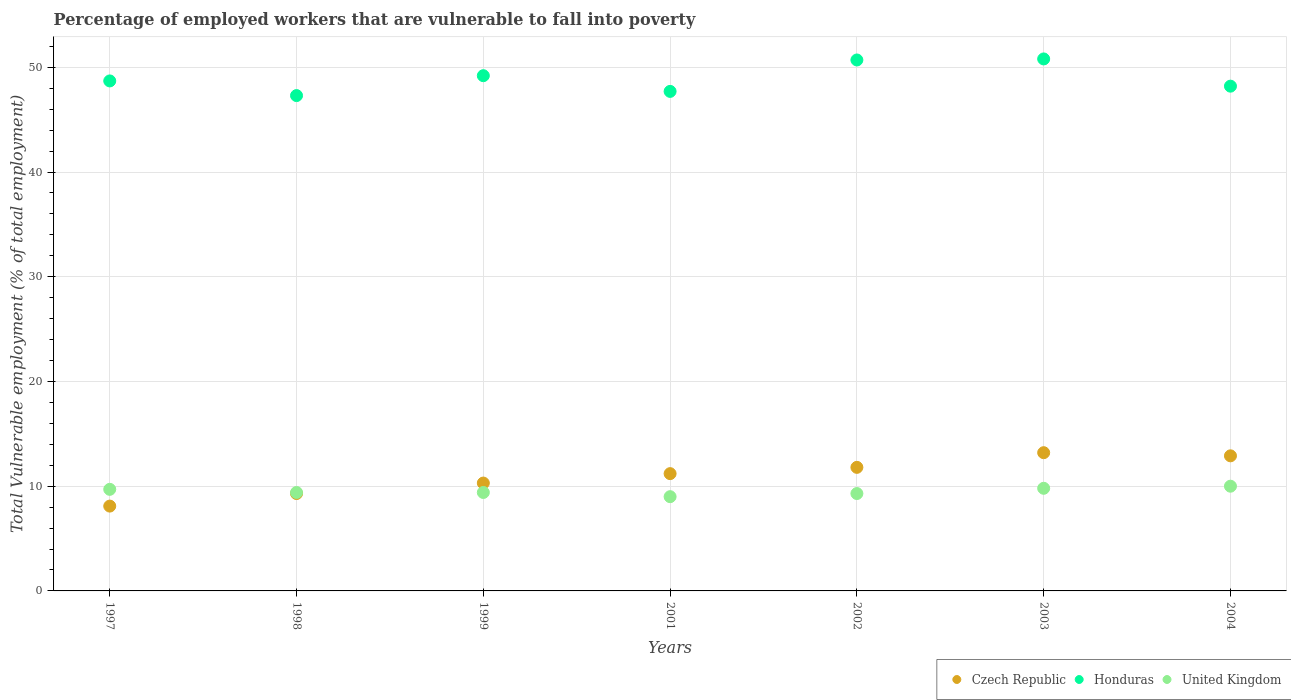How many different coloured dotlines are there?
Your answer should be compact. 3. What is the percentage of employed workers who are vulnerable to fall into poverty in United Kingdom in 2001?
Keep it short and to the point. 9. Across all years, what is the maximum percentage of employed workers who are vulnerable to fall into poverty in Honduras?
Provide a succinct answer. 50.8. Across all years, what is the minimum percentage of employed workers who are vulnerable to fall into poverty in Czech Republic?
Offer a very short reply. 8.1. What is the total percentage of employed workers who are vulnerable to fall into poverty in United Kingdom in the graph?
Ensure brevity in your answer.  66.6. What is the difference between the percentage of employed workers who are vulnerable to fall into poverty in Czech Republic in 2001 and that in 2002?
Offer a terse response. -0.6. What is the difference between the percentage of employed workers who are vulnerable to fall into poverty in Honduras in 2004 and the percentage of employed workers who are vulnerable to fall into poverty in United Kingdom in 2001?
Your response must be concise. 39.2. What is the average percentage of employed workers who are vulnerable to fall into poverty in Czech Republic per year?
Give a very brief answer. 10.97. In the year 1998, what is the difference between the percentage of employed workers who are vulnerable to fall into poverty in United Kingdom and percentage of employed workers who are vulnerable to fall into poverty in Czech Republic?
Offer a terse response. 0.1. What is the ratio of the percentage of employed workers who are vulnerable to fall into poverty in Honduras in 1997 to that in 2001?
Offer a very short reply. 1.02. Is the difference between the percentage of employed workers who are vulnerable to fall into poverty in United Kingdom in 1997 and 2004 greater than the difference between the percentage of employed workers who are vulnerable to fall into poverty in Czech Republic in 1997 and 2004?
Make the answer very short. Yes. What is the difference between the highest and the second highest percentage of employed workers who are vulnerable to fall into poverty in Czech Republic?
Provide a short and direct response. 0.3. What is the difference between the highest and the lowest percentage of employed workers who are vulnerable to fall into poverty in United Kingdom?
Your answer should be compact. 1. In how many years, is the percentage of employed workers who are vulnerable to fall into poverty in Honduras greater than the average percentage of employed workers who are vulnerable to fall into poverty in Honduras taken over all years?
Offer a very short reply. 3. Is the sum of the percentage of employed workers who are vulnerable to fall into poverty in Honduras in 2001 and 2004 greater than the maximum percentage of employed workers who are vulnerable to fall into poverty in Czech Republic across all years?
Your answer should be compact. Yes. Does the percentage of employed workers who are vulnerable to fall into poverty in Czech Republic monotonically increase over the years?
Keep it short and to the point. No. How many dotlines are there?
Your response must be concise. 3. How many years are there in the graph?
Provide a short and direct response. 7. What is the difference between two consecutive major ticks on the Y-axis?
Your answer should be very brief. 10. Does the graph contain any zero values?
Give a very brief answer. No. Does the graph contain grids?
Your answer should be very brief. Yes. Where does the legend appear in the graph?
Give a very brief answer. Bottom right. How many legend labels are there?
Provide a succinct answer. 3. How are the legend labels stacked?
Offer a very short reply. Horizontal. What is the title of the graph?
Keep it short and to the point. Percentage of employed workers that are vulnerable to fall into poverty. Does "Sint Maarten (Dutch part)" appear as one of the legend labels in the graph?
Offer a terse response. No. What is the label or title of the Y-axis?
Provide a succinct answer. Total Vulnerable employment (% of total employment). What is the Total Vulnerable employment (% of total employment) of Czech Republic in 1997?
Provide a short and direct response. 8.1. What is the Total Vulnerable employment (% of total employment) in Honduras in 1997?
Make the answer very short. 48.7. What is the Total Vulnerable employment (% of total employment) in United Kingdom in 1997?
Make the answer very short. 9.7. What is the Total Vulnerable employment (% of total employment) in Czech Republic in 1998?
Offer a terse response. 9.3. What is the Total Vulnerable employment (% of total employment) in Honduras in 1998?
Provide a short and direct response. 47.3. What is the Total Vulnerable employment (% of total employment) in United Kingdom in 1998?
Your answer should be compact. 9.4. What is the Total Vulnerable employment (% of total employment) of Czech Republic in 1999?
Make the answer very short. 10.3. What is the Total Vulnerable employment (% of total employment) in Honduras in 1999?
Provide a succinct answer. 49.2. What is the Total Vulnerable employment (% of total employment) in United Kingdom in 1999?
Your answer should be compact. 9.4. What is the Total Vulnerable employment (% of total employment) in Czech Republic in 2001?
Your answer should be very brief. 11.2. What is the Total Vulnerable employment (% of total employment) in Honduras in 2001?
Offer a very short reply. 47.7. What is the Total Vulnerable employment (% of total employment) in United Kingdom in 2001?
Give a very brief answer. 9. What is the Total Vulnerable employment (% of total employment) in Czech Republic in 2002?
Ensure brevity in your answer.  11.8. What is the Total Vulnerable employment (% of total employment) of Honduras in 2002?
Provide a succinct answer. 50.7. What is the Total Vulnerable employment (% of total employment) of United Kingdom in 2002?
Offer a terse response. 9.3. What is the Total Vulnerable employment (% of total employment) in Czech Republic in 2003?
Provide a succinct answer. 13.2. What is the Total Vulnerable employment (% of total employment) of Honduras in 2003?
Offer a terse response. 50.8. What is the Total Vulnerable employment (% of total employment) in United Kingdom in 2003?
Your response must be concise. 9.8. What is the Total Vulnerable employment (% of total employment) of Czech Republic in 2004?
Keep it short and to the point. 12.9. What is the Total Vulnerable employment (% of total employment) of Honduras in 2004?
Offer a terse response. 48.2. Across all years, what is the maximum Total Vulnerable employment (% of total employment) of Czech Republic?
Provide a short and direct response. 13.2. Across all years, what is the maximum Total Vulnerable employment (% of total employment) in Honduras?
Make the answer very short. 50.8. Across all years, what is the maximum Total Vulnerable employment (% of total employment) of United Kingdom?
Provide a short and direct response. 10. Across all years, what is the minimum Total Vulnerable employment (% of total employment) in Czech Republic?
Ensure brevity in your answer.  8.1. Across all years, what is the minimum Total Vulnerable employment (% of total employment) in Honduras?
Your answer should be very brief. 47.3. Across all years, what is the minimum Total Vulnerable employment (% of total employment) in United Kingdom?
Offer a very short reply. 9. What is the total Total Vulnerable employment (% of total employment) of Czech Republic in the graph?
Offer a very short reply. 76.8. What is the total Total Vulnerable employment (% of total employment) in Honduras in the graph?
Your answer should be compact. 342.6. What is the total Total Vulnerable employment (% of total employment) in United Kingdom in the graph?
Make the answer very short. 66.6. What is the difference between the Total Vulnerable employment (% of total employment) in Czech Republic in 1997 and that in 1998?
Provide a short and direct response. -1.2. What is the difference between the Total Vulnerable employment (% of total employment) in Czech Republic in 1997 and that in 2001?
Provide a succinct answer. -3.1. What is the difference between the Total Vulnerable employment (% of total employment) of Czech Republic in 1997 and that in 2002?
Make the answer very short. -3.7. What is the difference between the Total Vulnerable employment (% of total employment) in Honduras in 1997 and that in 2002?
Make the answer very short. -2. What is the difference between the Total Vulnerable employment (% of total employment) of United Kingdom in 1997 and that in 2002?
Provide a short and direct response. 0.4. What is the difference between the Total Vulnerable employment (% of total employment) of Czech Republic in 1997 and that in 2003?
Provide a succinct answer. -5.1. What is the difference between the Total Vulnerable employment (% of total employment) of Honduras in 1997 and that in 2003?
Make the answer very short. -2.1. What is the difference between the Total Vulnerable employment (% of total employment) in Honduras in 1997 and that in 2004?
Provide a short and direct response. 0.5. What is the difference between the Total Vulnerable employment (% of total employment) in United Kingdom in 1998 and that in 1999?
Provide a succinct answer. 0. What is the difference between the Total Vulnerable employment (% of total employment) of Czech Republic in 1998 and that in 2001?
Offer a very short reply. -1.9. What is the difference between the Total Vulnerable employment (% of total employment) in Honduras in 1998 and that in 2001?
Offer a very short reply. -0.4. What is the difference between the Total Vulnerable employment (% of total employment) of United Kingdom in 1998 and that in 2001?
Offer a very short reply. 0.4. What is the difference between the Total Vulnerable employment (% of total employment) in Czech Republic in 1998 and that in 2003?
Give a very brief answer. -3.9. What is the difference between the Total Vulnerable employment (% of total employment) of Czech Republic in 1998 and that in 2004?
Provide a short and direct response. -3.6. What is the difference between the Total Vulnerable employment (% of total employment) in Honduras in 1998 and that in 2004?
Make the answer very short. -0.9. What is the difference between the Total Vulnerable employment (% of total employment) of United Kingdom in 1998 and that in 2004?
Ensure brevity in your answer.  -0.6. What is the difference between the Total Vulnerable employment (% of total employment) in United Kingdom in 1999 and that in 2001?
Your answer should be very brief. 0.4. What is the difference between the Total Vulnerable employment (% of total employment) in Czech Republic in 1999 and that in 2002?
Provide a short and direct response. -1.5. What is the difference between the Total Vulnerable employment (% of total employment) in Honduras in 1999 and that in 2002?
Ensure brevity in your answer.  -1.5. What is the difference between the Total Vulnerable employment (% of total employment) in United Kingdom in 1999 and that in 2002?
Give a very brief answer. 0.1. What is the difference between the Total Vulnerable employment (% of total employment) of Czech Republic in 1999 and that in 2003?
Make the answer very short. -2.9. What is the difference between the Total Vulnerable employment (% of total employment) of Czech Republic in 1999 and that in 2004?
Ensure brevity in your answer.  -2.6. What is the difference between the Total Vulnerable employment (% of total employment) in Honduras in 1999 and that in 2004?
Keep it short and to the point. 1. What is the difference between the Total Vulnerable employment (% of total employment) in United Kingdom in 1999 and that in 2004?
Provide a short and direct response. -0.6. What is the difference between the Total Vulnerable employment (% of total employment) in Czech Republic in 2001 and that in 2002?
Offer a very short reply. -0.6. What is the difference between the Total Vulnerable employment (% of total employment) of Honduras in 2001 and that in 2002?
Provide a succinct answer. -3. What is the difference between the Total Vulnerable employment (% of total employment) of United Kingdom in 2001 and that in 2002?
Offer a very short reply. -0.3. What is the difference between the Total Vulnerable employment (% of total employment) of Czech Republic in 2001 and that in 2003?
Keep it short and to the point. -2. What is the difference between the Total Vulnerable employment (% of total employment) in Honduras in 2001 and that in 2003?
Make the answer very short. -3.1. What is the difference between the Total Vulnerable employment (% of total employment) in Honduras in 2001 and that in 2004?
Give a very brief answer. -0.5. What is the difference between the Total Vulnerable employment (% of total employment) in United Kingdom in 2001 and that in 2004?
Your answer should be very brief. -1. What is the difference between the Total Vulnerable employment (% of total employment) in Honduras in 2002 and that in 2003?
Your response must be concise. -0.1. What is the difference between the Total Vulnerable employment (% of total employment) of United Kingdom in 2002 and that in 2004?
Make the answer very short. -0.7. What is the difference between the Total Vulnerable employment (% of total employment) in Czech Republic in 2003 and that in 2004?
Offer a very short reply. 0.3. What is the difference between the Total Vulnerable employment (% of total employment) of Czech Republic in 1997 and the Total Vulnerable employment (% of total employment) of Honduras in 1998?
Your answer should be compact. -39.2. What is the difference between the Total Vulnerable employment (% of total employment) of Czech Republic in 1997 and the Total Vulnerable employment (% of total employment) of United Kingdom in 1998?
Provide a short and direct response. -1.3. What is the difference between the Total Vulnerable employment (% of total employment) in Honduras in 1997 and the Total Vulnerable employment (% of total employment) in United Kingdom in 1998?
Give a very brief answer. 39.3. What is the difference between the Total Vulnerable employment (% of total employment) of Czech Republic in 1997 and the Total Vulnerable employment (% of total employment) of Honduras in 1999?
Provide a succinct answer. -41.1. What is the difference between the Total Vulnerable employment (% of total employment) in Czech Republic in 1997 and the Total Vulnerable employment (% of total employment) in United Kingdom in 1999?
Give a very brief answer. -1.3. What is the difference between the Total Vulnerable employment (% of total employment) of Honduras in 1997 and the Total Vulnerable employment (% of total employment) of United Kingdom in 1999?
Make the answer very short. 39.3. What is the difference between the Total Vulnerable employment (% of total employment) in Czech Republic in 1997 and the Total Vulnerable employment (% of total employment) in Honduras in 2001?
Make the answer very short. -39.6. What is the difference between the Total Vulnerable employment (% of total employment) of Czech Republic in 1997 and the Total Vulnerable employment (% of total employment) of United Kingdom in 2001?
Your answer should be compact. -0.9. What is the difference between the Total Vulnerable employment (% of total employment) in Honduras in 1997 and the Total Vulnerable employment (% of total employment) in United Kingdom in 2001?
Ensure brevity in your answer.  39.7. What is the difference between the Total Vulnerable employment (% of total employment) in Czech Republic in 1997 and the Total Vulnerable employment (% of total employment) in Honduras in 2002?
Offer a terse response. -42.6. What is the difference between the Total Vulnerable employment (% of total employment) of Honduras in 1997 and the Total Vulnerable employment (% of total employment) of United Kingdom in 2002?
Make the answer very short. 39.4. What is the difference between the Total Vulnerable employment (% of total employment) in Czech Republic in 1997 and the Total Vulnerable employment (% of total employment) in Honduras in 2003?
Provide a succinct answer. -42.7. What is the difference between the Total Vulnerable employment (% of total employment) in Honduras in 1997 and the Total Vulnerable employment (% of total employment) in United Kingdom in 2003?
Give a very brief answer. 38.9. What is the difference between the Total Vulnerable employment (% of total employment) of Czech Republic in 1997 and the Total Vulnerable employment (% of total employment) of Honduras in 2004?
Offer a very short reply. -40.1. What is the difference between the Total Vulnerable employment (% of total employment) in Czech Republic in 1997 and the Total Vulnerable employment (% of total employment) in United Kingdom in 2004?
Keep it short and to the point. -1.9. What is the difference between the Total Vulnerable employment (% of total employment) in Honduras in 1997 and the Total Vulnerable employment (% of total employment) in United Kingdom in 2004?
Offer a very short reply. 38.7. What is the difference between the Total Vulnerable employment (% of total employment) of Czech Republic in 1998 and the Total Vulnerable employment (% of total employment) of Honduras in 1999?
Make the answer very short. -39.9. What is the difference between the Total Vulnerable employment (% of total employment) of Honduras in 1998 and the Total Vulnerable employment (% of total employment) of United Kingdom in 1999?
Offer a very short reply. 37.9. What is the difference between the Total Vulnerable employment (% of total employment) in Czech Republic in 1998 and the Total Vulnerable employment (% of total employment) in Honduras in 2001?
Offer a very short reply. -38.4. What is the difference between the Total Vulnerable employment (% of total employment) in Czech Republic in 1998 and the Total Vulnerable employment (% of total employment) in United Kingdom in 2001?
Make the answer very short. 0.3. What is the difference between the Total Vulnerable employment (% of total employment) in Honduras in 1998 and the Total Vulnerable employment (% of total employment) in United Kingdom in 2001?
Provide a short and direct response. 38.3. What is the difference between the Total Vulnerable employment (% of total employment) in Czech Republic in 1998 and the Total Vulnerable employment (% of total employment) in Honduras in 2002?
Ensure brevity in your answer.  -41.4. What is the difference between the Total Vulnerable employment (% of total employment) in Czech Republic in 1998 and the Total Vulnerable employment (% of total employment) in United Kingdom in 2002?
Ensure brevity in your answer.  0. What is the difference between the Total Vulnerable employment (% of total employment) in Honduras in 1998 and the Total Vulnerable employment (% of total employment) in United Kingdom in 2002?
Your response must be concise. 38. What is the difference between the Total Vulnerable employment (% of total employment) of Czech Republic in 1998 and the Total Vulnerable employment (% of total employment) of Honduras in 2003?
Your answer should be very brief. -41.5. What is the difference between the Total Vulnerable employment (% of total employment) of Honduras in 1998 and the Total Vulnerable employment (% of total employment) of United Kingdom in 2003?
Keep it short and to the point. 37.5. What is the difference between the Total Vulnerable employment (% of total employment) in Czech Republic in 1998 and the Total Vulnerable employment (% of total employment) in Honduras in 2004?
Your response must be concise. -38.9. What is the difference between the Total Vulnerable employment (% of total employment) of Czech Republic in 1998 and the Total Vulnerable employment (% of total employment) of United Kingdom in 2004?
Offer a terse response. -0.7. What is the difference between the Total Vulnerable employment (% of total employment) of Honduras in 1998 and the Total Vulnerable employment (% of total employment) of United Kingdom in 2004?
Offer a terse response. 37.3. What is the difference between the Total Vulnerable employment (% of total employment) of Czech Republic in 1999 and the Total Vulnerable employment (% of total employment) of Honduras in 2001?
Your answer should be very brief. -37.4. What is the difference between the Total Vulnerable employment (% of total employment) of Czech Republic in 1999 and the Total Vulnerable employment (% of total employment) of United Kingdom in 2001?
Your answer should be compact. 1.3. What is the difference between the Total Vulnerable employment (% of total employment) of Honduras in 1999 and the Total Vulnerable employment (% of total employment) of United Kingdom in 2001?
Your answer should be very brief. 40.2. What is the difference between the Total Vulnerable employment (% of total employment) in Czech Republic in 1999 and the Total Vulnerable employment (% of total employment) in Honduras in 2002?
Ensure brevity in your answer.  -40.4. What is the difference between the Total Vulnerable employment (% of total employment) of Honduras in 1999 and the Total Vulnerable employment (% of total employment) of United Kingdom in 2002?
Your answer should be compact. 39.9. What is the difference between the Total Vulnerable employment (% of total employment) in Czech Republic in 1999 and the Total Vulnerable employment (% of total employment) in Honduras in 2003?
Provide a short and direct response. -40.5. What is the difference between the Total Vulnerable employment (% of total employment) in Honduras in 1999 and the Total Vulnerable employment (% of total employment) in United Kingdom in 2003?
Give a very brief answer. 39.4. What is the difference between the Total Vulnerable employment (% of total employment) in Czech Republic in 1999 and the Total Vulnerable employment (% of total employment) in Honduras in 2004?
Offer a very short reply. -37.9. What is the difference between the Total Vulnerable employment (% of total employment) in Honduras in 1999 and the Total Vulnerable employment (% of total employment) in United Kingdom in 2004?
Your answer should be very brief. 39.2. What is the difference between the Total Vulnerable employment (% of total employment) in Czech Republic in 2001 and the Total Vulnerable employment (% of total employment) in Honduras in 2002?
Offer a terse response. -39.5. What is the difference between the Total Vulnerable employment (% of total employment) in Honduras in 2001 and the Total Vulnerable employment (% of total employment) in United Kingdom in 2002?
Your answer should be compact. 38.4. What is the difference between the Total Vulnerable employment (% of total employment) in Czech Republic in 2001 and the Total Vulnerable employment (% of total employment) in Honduras in 2003?
Offer a terse response. -39.6. What is the difference between the Total Vulnerable employment (% of total employment) of Czech Republic in 2001 and the Total Vulnerable employment (% of total employment) of United Kingdom in 2003?
Ensure brevity in your answer.  1.4. What is the difference between the Total Vulnerable employment (% of total employment) in Honduras in 2001 and the Total Vulnerable employment (% of total employment) in United Kingdom in 2003?
Keep it short and to the point. 37.9. What is the difference between the Total Vulnerable employment (% of total employment) of Czech Republic in 2001 and the Total Vulnerable employment (% of total employment) of Honduras in 2004?
Your response must be concise. -37. What is the difference between the Total Vulnerable employment (% of total employment) of Czech Republic in 2001 and the Total Vulnerable employment (% of total employment) of United Kingdom in 2004?
Your answer should be very brief. 1.2. What is the difference between the Total Vulnerable employment (% of total employment) of Honduras in 2001 and the Total Vulnerable employment (% of total employment) of United Kingdom in 2004?
Your response must be concise. 37.7. What is the difference between the Total Vulnerable employment (% of total employment) of Czech Republic in 2002 and the Total Vulnerable employment (% of total employment) of Honduras in 2003?
Your response must be concise. -39. What is the difference between the Total Vulnerable employment (% of total employment) in Honduras in 2002 and the Total Vulnerable employment (% of total employment) in United Kingdom in 2003?
Provide a short and direct response. 40.9. What is the difference between the Total Vulnerable employment (% of total employment) of Czech Republic in 2002 and the Total Vulnerable employment (% of total employment) of Honduras in 2004?
Give a very brief answer. -36.4. What is the difference between the Total Vulnerable employment (% of total employment) of Honduras in 2002 and the Total Vulnerable employment (% of total employment) of United Kingdom in 2004?
Make the answer very short. 40.7. What is the difference between the Total Vulnerable employment (% of total employment) of Czech Republic in 2003 and the Total Vulnerable employment (% of total employment) of Honduras in 2004?
Ensure brevity in your answer.  -35. What is the difference between the Total Vulnerable employment (% of total employment) of Honduras in 2003 and the Total Vulnerable employment (% of total employment) of United Kingdom in 2004?
Ensure brevity in your answer.  40.8. What is the average Total Vulnerable employment (% of total employment) of Czech Republic per year?
Make the answer very short. 10.97. What is the average Total Vulnerable employment (% of total employment) in Honduras per year?
Your answer should be compact. 48.94. What is the average Total Vulnerable employment (% of total employment) of United Kingdom per year?
Offer a very short reply. 9.51. In the year 1997, what is the difference between the Total Vulnerable employment (% of total employment) of Czech Republic and Total Vulnerable employment (% of total employment) of Honduras?
Make the answer very short. -40.6. In the year 1997, what is the difference between the Total Vulnerable employment (% of total employment) in Czech Republic and Total Vulnerable employment (% of total employment) in United Kingdom?
Ensure brevity in your answer.  -1.6. In the year 1998, what is the difference between the Total Vulnerable employment (% of total employment) in Czech Republic and Total Vulnerable employment (% of total employment) in Honduras?
Keep it short and to the point. -38. In the year 1998, what is the difference between the Total Vulnerable employment (% of total employment) in Honduras and Total Vulnerable employment (% of total employment) in United Kingdom?
Provide a short and direct response. 37.9. In the year 1999, what is the difference between the Total Vulnerable employment (% of total employment) in Czech Republic and Total Vulnerable employment (% of total employment) in Honduras?
Your answer should be compact. -38.9. In the year 1999, what is the difference between the Total Vulnerable employment (% of total employment) in Czech Republic and Total Vulnerable employment (% of total employment) in United Kingdom?
Your answer should be compact. 0.9. In the year 1999, what is the difference between the Total Vulnerable employment (% of total employment) in Honduras and Total Vulnerable employment (% of total employment) in United Kingdom?
Your answer should be compact. 39.8. In the year 2001, what is the difference between the Total Vulnerable employment (% of total employment) in Czech Republic and Total Vulnerable employment (% of total employment) in Honduras?
Provide a succinct answer. -36.5. In the year 2001, what is the difference between the Total Vulnerable employment (% of total employment) in Honduras and Total Vulnerable employment (% of total employment) in United Kingdom?
Give a very brief answer. 38.7. In the year 2002, what is the difference between the Total Vulnerable employment (% of total employment) of Czech Republic and Total Vulnerable employment (% of total employment) of Honduras?
Keep it short and to the point. -38.9. In the year 2002, what is the difference between the Total Vulnerable employment (% of total employment) in Honduras and Total Vulnerable employment (% of total employment) in United Kingdom?
Your answer should be compact. 41.4. In the year 2003, what is the difference between the Total Vulnerable employment (% of total employment) in Czech Republic and Total Vulnerable employment (% of total employment) in Honduras?
Make the answer very short. -37.6. In the year 2003, what is the difference between the Total Vulnerable employment (% of total employment) in Czech Republic and Total Vulnerable employment (% of total employment) in United Kingdom?
Your answer should be very brief. 3.4. In the year 2003, what is the difference between the Total Vulnerable employment (% of total employment) in Honduras and Total Vulnerable employment (% of total employment) in United Kingdom?
Offer a very short reply. 41. In the year 2004, what is the difference between the Total Vulnerable employment (% of total employment) of Czech Republic and Total Vulnerable employment (% of total employment) of Honduras?
Ensure brevity in your answer.  -35.3. In the year 2004, what is the difference between the Total Vulnerable employment (% of total employment) of Honduras and Total Vulnerable employment (% of total employment) of United Kingdom?
Ensure brevity in your answer.  38.2. What is the ratio of the Total Vulnerable employment (% of total employment) in Czech Republic in 1997 to that in 1998?
Keep it short and to the point. 0.87. What is the ratio of the Total Vulnerable employment (% of total employment) in Honduras in 1997 to that in 1998?
Your answer should be compact. 1.03. What is the ratio of the Total Vulnerable employment (% of total employment) in United Kingdom in 1997 to that in 1998?
Keep it short and to the point. 1.03. What is the ratio of the Total Vulnerable employment (% of total employment) in Czech Republic in 1997 to that in 1999?
Make the answer very short. 0.79. What is the ratio of the Total Vulnerable employment (% of total employment) in Honduras in 1997 to that in 1999?
Your response must be concise. 0.99. What is the ratio of the Total Vulnerable employment (% of total employment) of United Kingdom in 1997 to that in 1999?
Keep it short and to the point. 1.03. What is the ratio of the Total Vulnerable employment (% of total employment) in Czech Republic in 1997 to that in 2001?
Provide a short and direct response. 0.72. What is the ratio of the Total Vulnerable employment (% of total employment) in United Kingdom in 1997 to that in 2001?
Give a very brief answer. 1.08. What is the ratio of the Total Vulnerable employment (% of total employment) of Czech Republic in 1997 to that in 2002?
Your answer should be very brief. 0.69. What is the ratio of the Total Vulnerable employment (% of total employment) in Honduras in 1997 to that in 2002?
Provide a short and direct response. 0.96. What is the ratio of the Total Vulnerable employment (% of total employment) in United Kingdom in 1997 to that in 2002?
Make the answer very short. 1.04. What is the ratio of the Total Vulnerable employment (% of total employment) in Czech Republic in 1997 to that in 2003?
Keep it short and to the point. 0.61. What is the ratio of the Total Vulnerable employment (% of total employment) in Honduras in 1997 to that in 2003?
Your answer should be very brief. 0.96. What is the ratio of the Total Vulnerable employment (% of total employment) in United Kingdom in 1997 to that in 2003?
Give a very brief answer. 0.99. What is the ratio of the Total Vulnerable employment (% of total employment) of Czech Republic in 1997 to that in 2004?
Offer a terse response. 0.63. What is the ratio of the Total Vulnerable employment (% of total employment) in Honduras in 1997 to that in 2004?
Keep it short and to the point. 1.01. What is the ratio of the Total Vulnerable employment (% of total employment) in United Kingdom in 1997 to that in 2004?
Provide a short and direct response. 0.97. What is the ratio of the Total Vulnerable employment (% of total employment) in Czech Republic in 1998 to that in 1999?
Make the answer very short. 0.9. What is the ratio of the Total Vulnerable employment (% of total employment) of Honduras in 1998 to that in 1999?
Your answer should be very brief. 0.96. What is the ratio of the Total Vulnerable employment (% of total employment) of United Kingdom in 1998 to that in 1999?
Ensure brevity in your answer.  1. What is the ratio of the Total Vulnerable employment (% of total employment) in Czech Republic in 1998 to that in 2001?
Your answer should be very brief. 0.83. What is the ratio of the Total Vulnerable employment (% of total employment) in Honduras in 1998 to that in 2001?
Your response must be concise. 0.99. What is the ratio of the Total Vulnerable employment (% of total employment) in United Kingdom in 1998 to that in 2001?
Your answer should be very brief. 1.04. What is the ratio of the Total Vulnerable employment (% of total employment) in Czech Republic in 1998 to that in 2002?
Make the answer very short. 0.79. What is the ratio of the Total Vulnerable employment (% of total employment) in Honduras in 1998 to that in 2002?
Provide a short and direct response. 0.93. What is the ratio of the Total Vulnerable employment (% of total employment) of United Kingdom in 1998 to that in 2002?
Ensure brevity in your answer.  1.01. What is the ratio of the Total Vulnerable employment (% of total employment) in Czech Republic in 1998 to that in 2003?
Provide a short and direct response. 0.7. What is the ratio of the Total Vulnerable employment (% of total employment) of Honduras in 1998 to that in 2003?
Ensure brevity in your answer.  0.93. What is the ratio of the Total Vulnerable employment (% of total employment) in United Kingdom in 1998 to that in 2003?
Keep it short and to the point. 0.96. What is the ratio of the Total Vulnerable employment (% of total employment) of Czech Republic in 1998 to that in 2004?
Offer a terse response. 0.72. What is the ratio of the Total Vulnerable employment (% of total employment) in Honduras in 1998 to that in 2004?
Give a very brief answer. 0.98. What is the ratio of the Total Vulnerable employment (% of total employment) of United Kingdom in 1998 to that in 2004?
Offer a very short reply. 0.94. What is the ratio of the Total Vulnerable employment (% of total employment) in Czech Republic in 1999 to that in 2001?
Give a very brief answer. 0.92. What is the ratio of the Total Vulnerable employment (% of total employment) in Honduras in 1999 to that in 2001?
Your answer should be compact. 1.03. What is the ratio of the Total Vulnerable employment (% of total employment) in United Kingdom in 1999 to that in 2001?
Provide a succinct answer. 1.04. What is the ratio of the Total Vulnerable employment (% of total employment) of Czech Republic in 1999 to that in 2002?
Ensure brevity in your answer.  0.87. What is the ratio of the Total Vulnerable employment (% of total employment) in Honduras in 1999 to that in 2002?
Ensure brevity in your answer.  0.97. What is the ratio of the Total Vulnerable employment (% of total employment) in United Kingdom in 1999 to that in 2002?
Ensure brevity in your answer.  1.01. What is the ratio of the Total Vulnerable employment (% of total employment) of Czech Republic in 1999 to that in 2003?
Provide a succinct answer. 0.78. What is the ratio of the Total Vulnerable employment (% of total employment) of Honduras in 1999 to that in 2003?
Provide a succinct answer. 0.97. What is the ratio of the Total Vulnerable employment (% of total employment) in United Kingdom in 1999 to that in 2003?
Your answer should be very brief. 0.96. What is the ratio of the Total Vulnerable employment (% of total employment) of Czech Republic in 1999 to that in 2004?
Give a very brief answer. 0.8. What is the ratio of the Total Vulnerable employment (% of total employment) in Honduras in 1999 to that in 2004?
Ensure brevity in your answer.  1.02. What is the ratio of the Total Vulnerable employment (% of total employment) of Czech Republic in 2001 to that in 2002?
Provide a short and direct response. 0.95. What is the ratio of the Total Vulnerable employment (% of total employment) in Honduras in 2001 to that in 2002?
Your response must be concise. 0.94. What is the ratio of the Total Vulnerable employment (% of total employment) in United Kingdom in 2001 to that in 2002?
Your answer should be compact. 0.97. What is the ratio of the Total Vulnerable employment (% of total employment) in Czech Republic in 2001 to that in 2003?
Keep it short and to the point. 0.85. What is the ratio of the Total Vulnerable employment (% of total employment) of Honduras in 2001 to that in 2003?
Give a very brief answer. 0.94. What is the ratio of the Total Vulnerable employment (% of total employment) in United Kingdom in 2001 to that in 2003?
Provide a short and direct response. 0.92. What is the ratio of the Total Vulnerable employment (% of total employment) of Czech Republic in 2001 to that in 2004?
Ensure brevity in your answer.  0.87. What is the ratio of the Total Vulnerable employment (% of total employment) in Czech Republic in 2002 to that in 2003?
Keep it short and to the point. 0.89. What is the ratio of the Total Vulnerable employment (% of total employment) in United Kingdom in 2002 to that in 2003?
Your response must be concise. 0.95. What is the ratio of the Total Vulnerable employment (% of total employment) of Czech Republic in 2002 to that in 2004?
Your answer should be very brief. 0.91. What is the ratio of the Total Vulnerable employment (% of total employment) of Honduras in 2002 to that in 2004?
Provide a short and direct response. 1.05. What is the ratio of the Total Vulnerable employment (% of total employment) of United Kingdom in 2002 to that in 2004?
Provide a succinct answer. 0.93. What is the ratio of the Total Vulnerable employment (% of total employment) of Czech Republic in 2003 to that in 2004?
Provide a succinct answer. 1.02. What is the ratio of the Total Vulnerable employment (% of total employment) of Honduras in 2003 to that in 2004?
Offer a terse response. 1.05. What is the difference between the highest and the second highest Total Vulnerable employment (% of total employment) in United Kingdom?
Offer a terse response. 0.2. What is the difference between the highest and the lowest Total Vulnerable employment (% of total employment) of Czech Republic?
Offer a terse response. 5.1. What is the difference between the highest and the lowest Total Vulnerable employment (% of total employment) in United Kingdom?
Your response must be concise. 1. 